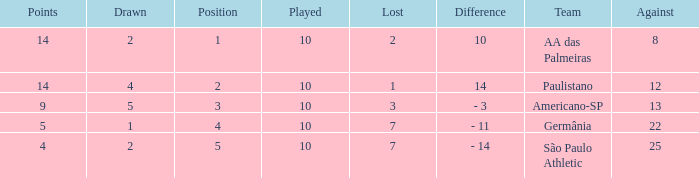What is the sum of Against when the lost is more than 7? None. 